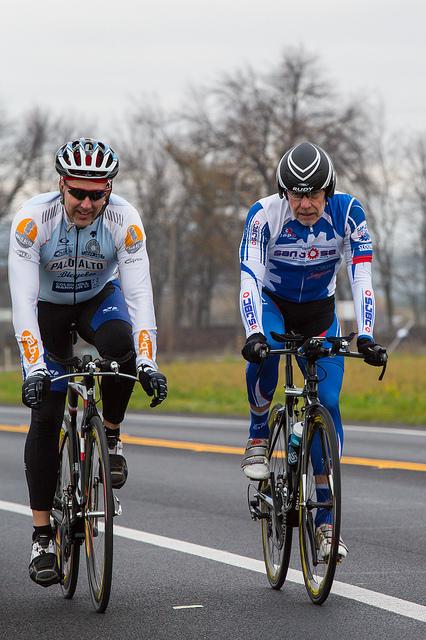What are they doing?
Be succinct. Riding bikes. What are men wearing on their heads?
Quick response, please. Helmets. How many men are there?
Keep it brief. 2. 